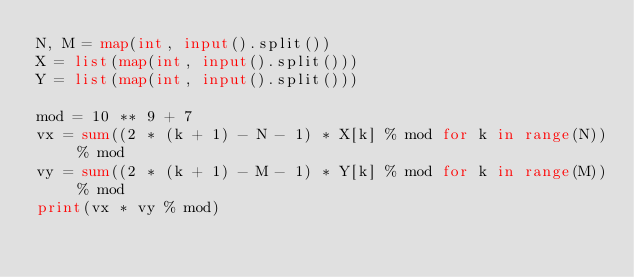<code> <loc_0><loc_0><loc_500><loc_500><_Python_>N, M = map(int, input().split())
X = list(map(int, input().split()))
Y = list(map(int, input().split()))

mod = 10 ** 9 + 7
vx = sum((2 * (k + 1) - N - 1) * X[k] % mod for k in range(N)) % mod
vy = sum((2 * (k + 1) - M - 1) * Y[k] % mod for k in range(M)) % mod
print(vx * vy % mod)
</code> 